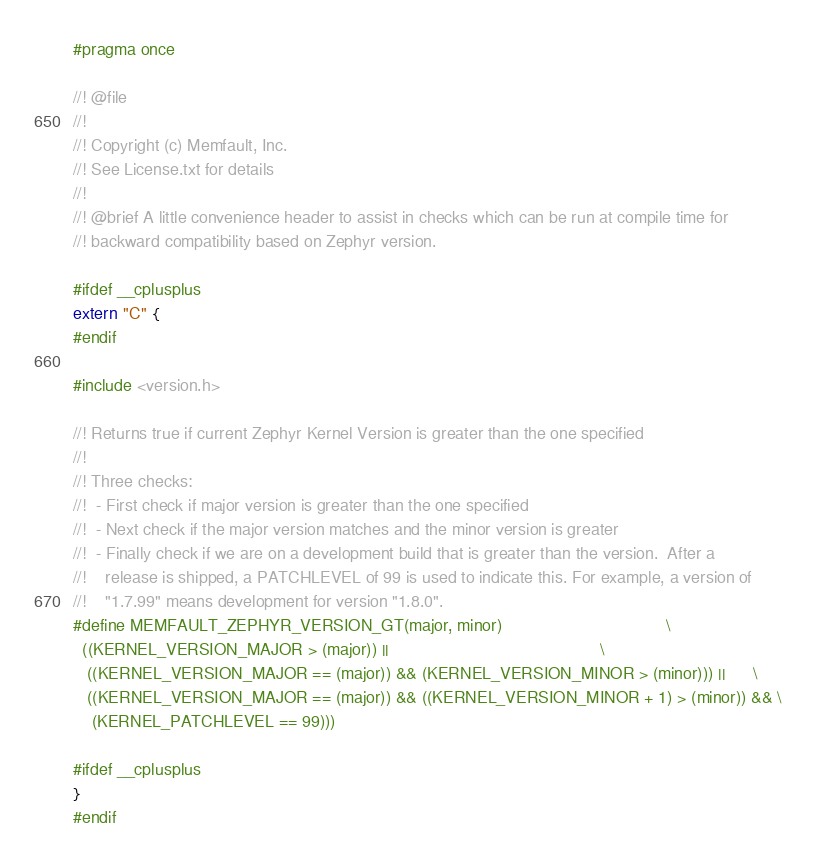Convert code to text. <code><loc_0><loc_0><loc_500><loc_500><_C_>#pragma once

//! @file
//!
//! Copyright (c) Memfault, Inc.
//! See License.txt for details
//!
//! @brief A little convenience header to assist in checks which can be run at compile time for
//! backward compatibility based on Zephyr version.

#ifdef __cplusplus
extern "C" {
#endif

#include <version.h>

//! Returns true if current Zephyr Kernel Version is greater than the one specified
//!
//! Three checks:
//!  - First check if major version is greater than the one specified
//!  - Next check if the major version matches and the minor version is greater
//!  - Finally check if we are on a development build that is greater than the version.  After a
//!    release is shipped, a PATCHLEVEL of 99 is used to indicate this. For example, a version of
//!    "1.7.99" means development for version "1.8.0".
#define MEMFAULT_ZEPHYR_VERSION_GT(major, minor)                                   \
  ((KERNEL_VERSION_MAJOR > (major)) ||                                             \
   ((KERNEL_VERSION_MAJOR == (major)) && (KERNEL_VERSION_MINOR > (minor))) ||      \
   ((KERNEL_VERSION_MAJOR == (major)) && ((KERNEL_VERSION_MINOR + 1) > (minor)) && \
    (KERNEL_PATCHLEVEL == 99)))

#ifdef __cplusplus
}
#endif
</code> 